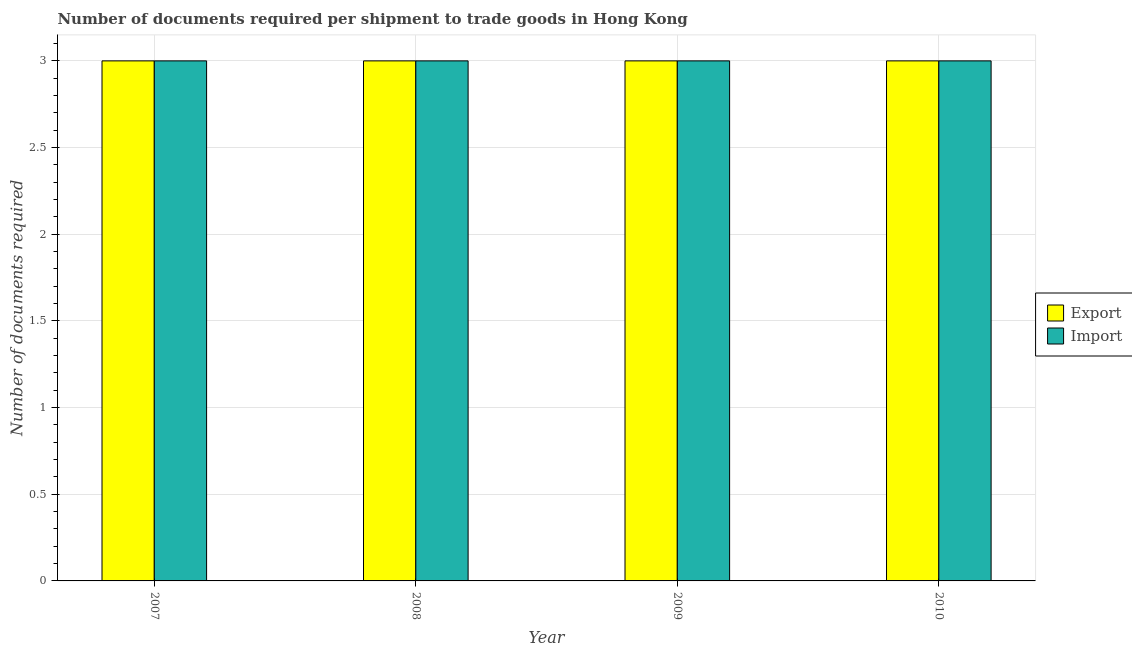What is the label of the 1st group of bars from the left?
Your answer should be very brief. 2007. In how many cases, is the number of bars for a given year not equal to the number of legend labels?
Your answer should be very brief. 0. What is the number of documents required to import goods in 2009?
Give a very brief answer. 3. Across all years, what is the maximum number of documents required to import goods?
Your answer should be compact. 3. Across all years, what is the minimum number of documents required to export goods?
Keep it short and to the point. 3. In which year was the number of documents required to export goods maximum?
Keep it short and to the point. 2007. What is the total number of documents required to import goods in the graph?
Provide a short and direct response. 12. What is the difference between the number of documents required to import goods in 2007 and that in 2009?
Your response must be concise. 0. What is the average number of documents required to import goods per year?
Your answer should be compact. 3. In how many years, is the number of documents required to import goods greater than 2.2?
Your response must be concise. 4. What is the difference between the highest and the second highest number of documents required to import goods?
Your answer should be very brief. 0. What is the difference between the highest and the lowest number of documents required to export goods?
Provide a succinct answer. 0. In how many years, is the number of documents required to import goods greater than the average number of documents required to import goods taken over all years?
Make the answer very short. 0. What does the 1st bar from the left in 2007 represents?
Keep it short and to the point. Export. What does the 1st bar from the right in 2010 represents?
Ensure brevity in your answer.  Import. Are all the bars in the graph horizontal?
Give a very brief answer. No. How many years are there in the graph?
Keep it short and to the point. 4. What is the difference between two consecutive major ticks on the Y-axis?
Offer a terse response. 0.5. Does the graph contain grids?
Your answer should be very brief. Yes. Where does the legend appear in the graph?
Give a very brief answer. Center right. How many legend labels are there?
Provide a succinct answer. 2. What is the title of the graph?
Your answer should be compact. Number of documents required per shipment to trade goods in Hong Kong. What is the label or title of the X-axis?
Provide a succinct answer. Year. What is the label or title of the Y-axis?
Give a very brief answer. Number of documents required. What is the Number of documents required of Export in 2007?
Offer a very short reply. 3. What is the Number of documents required in Export in 2008?
Ensure brevity in your answer.  3. What is the Number of documents required in Import in 2008?
Offer a very short reply. 3. What is the Number of documents required in Import in 2010?
Provide a short and direct response. 3. Across all years, what is the maximum Number of documents required of Export?
Keep it short and to the point. 3. Across all years, what is the minimum Number of documents required in Import?
Your response must be concise. 3. What is the difference between the Number of documents required of Export in 2007 and that in 2008?
Your answer should be compact. 0. What is the difference between the Number of documents required in Export in 2007 and that in 2009?
Provide a succinct answer. 0. What is the difference between the Number of documents required in Import in 2007 and that in 2009?
Your response must be concise. 0. What is the difference between the Number of documents required of Export in 2007 and that in 2010?
Make the answer very short. 0. What is the difference between the Number of documents required in Import in 2007 and that in 2010?
Provide a succinct answer. 0. What is the difference between the Number of documents required of Export in 2008 and that in 2010?
Make the answer very short. 0. What is the difference between the Number of documents required in Export in 2009 and that in 2010?
Provide a succinct answer. 0. What is the difference between the Number of documents required of Import in 2009 and that in 2010?
Make the answer very short. 0. What is the difference between the Number of documents required in Export in 2007 and the Number of documents required in Import in 2009?
Ensure brevity in your answer.  0. What is the difference between the Number of documents required of Export in 2008 and the Number of documents required of Import in 2009?
Your answer should be very brief. 0. What is the difference between the Number of documents required of Export in 2009 and the Number of documents required of Import in 2010?
Offer a terse response. 0. In the year 2007, what is the difference between the Number of documents required in Export and Number of documents required in Import?
Provide a short and direct response. 0. In the year 2009, what is the difference between the Number of documents required of Export and Number of documents required of Import?
Provide a short and direct response. 0. In the year 2010, what is the difference between the Number of documents required in Export and Number of documents required in Import?
Provide a succinct answer. 0. What is the ratio of the Number of documents required of Export in 2007 to that in 2008?
Give a very brief answer. 1. What is the ratio of the Number of documents required in Import in 2007 to that in 2008?
Provide a short and direct response. 1. What is the ratio of the Number of documents required in Import in 2007 to that in 2009?
Ensure brevity in your answer.  1. What is the ratio of the Number of documents required of Import in 2008 to that in 2009?
Make the answer very short. 1. What is the ratio of the Number of documents required of Export in 2008 to that in 2010?
Offer a very short reply. 1. What is the ratio of the Number of documents required of Import in 2008 to that in 2010?
Ensure brevity in your answer.  1. What is the difference between the highest and the second highest Number of documents required in Export?
Offer a very short reply. 0. What is the difference between the highest and the second highest Number of documents required of Import?
Provide a succinct answer. 0. What is the difference between the highest and the lowest Number of documents required of Export?
Your answer should be very brief. 0. What is the difference between the highest and the lowest Number of documents required of Import?
Offer a very short reply. 0. 